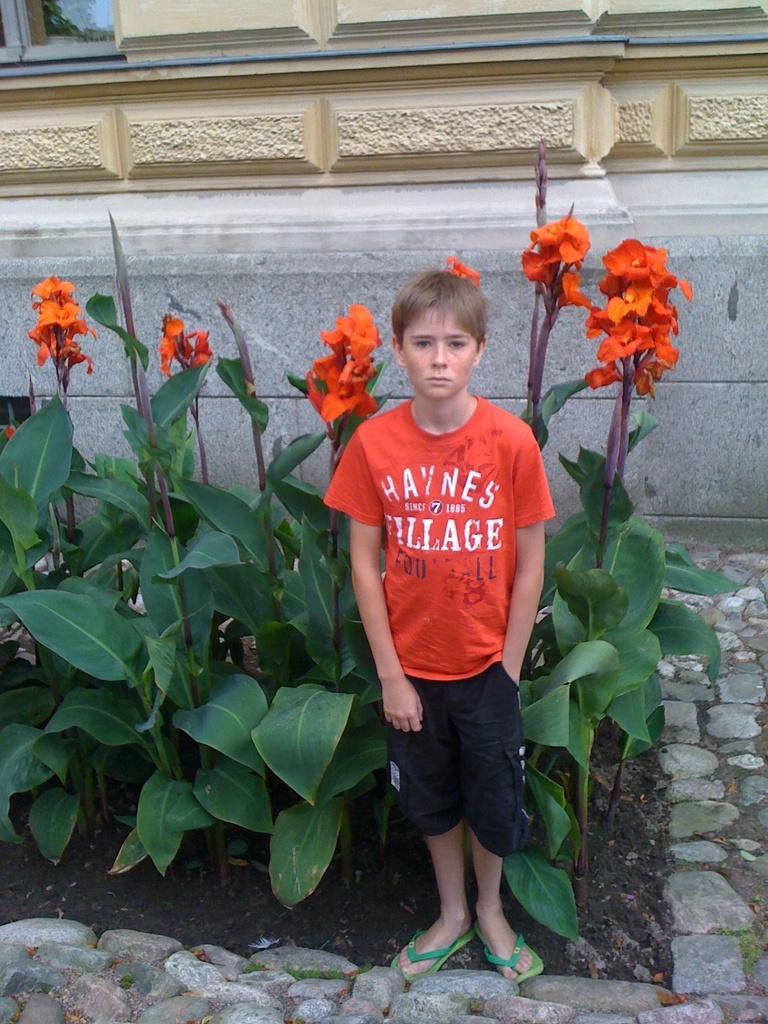Could you give a brief overview of what you see in this image? In front of the image there is a kid standing, behind the kid there are plants with leaves and flowers, the kid is standing on the rock surface, behind the kid there is a building. 